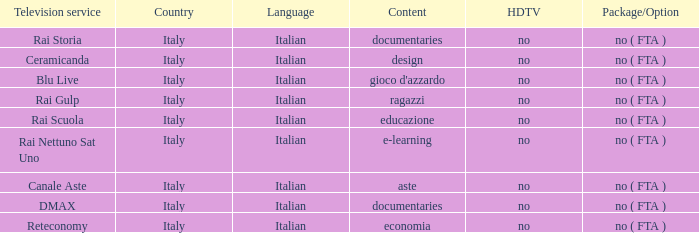What is the Language for Canale Aste? Italian. 